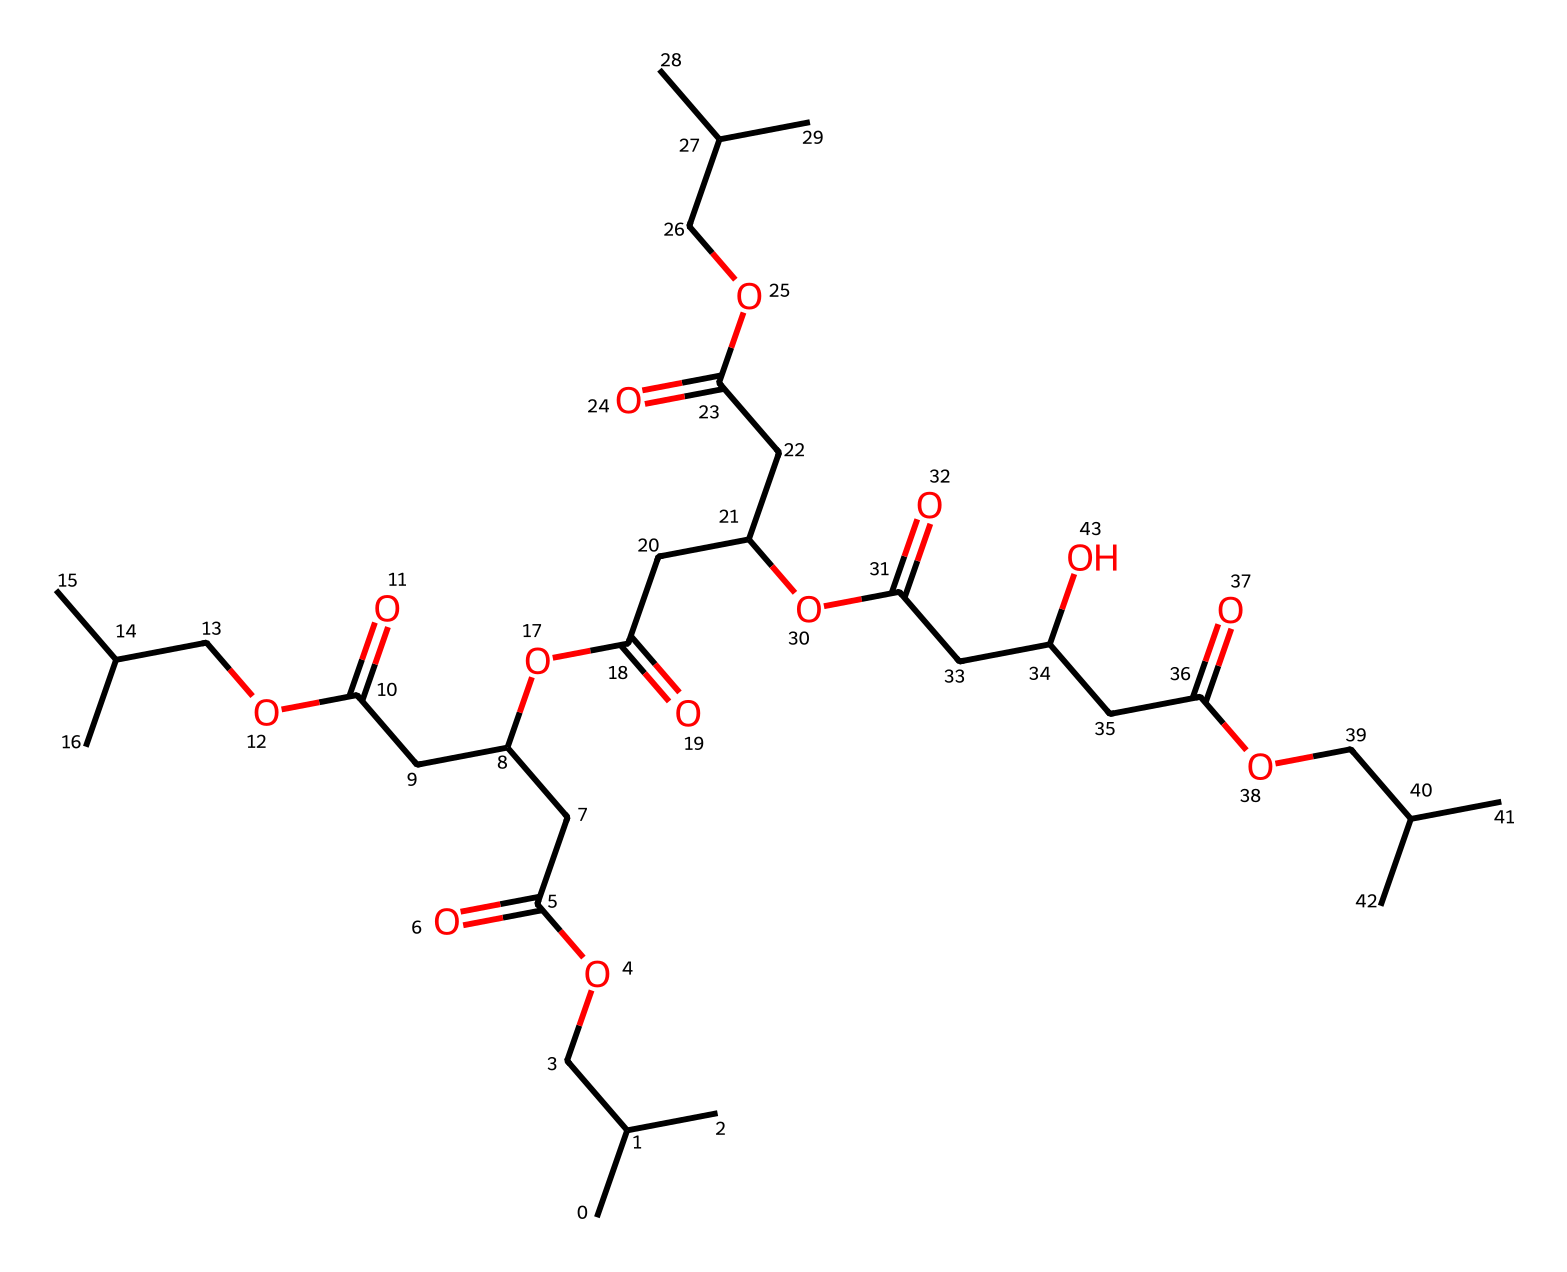What is the primary functional group present in this chemical? The chemical features ester bonds, identifiable from the O=C and O segments within the structure. These are characteristic of esters, derived from carboxylic acids and alcohols.
Answer: ester How many carbon atoms are in this structure? By counting each "C" in the SMILES representation and accounting for the branching, there are 21 carbon atoms in total.
Answer: 21 What type of biomolecule is represented by this chemical? This chemical is a polymer made from biological monomers, typically representing a type of biodegradable plastic used in waste management applications.
Answer: polymer How many ester linkages are present in this molecule? The presence of multiple O=C segments indicates there are three repeating ester linkages, evident in the branched structure of the molecule.
Answer: three Does this chemical exhibit hydrophilic or hydrophobic characteristics? The presence of multiple ester and carboxylic acid groups indicates this molecule is hydrophilic, allowing for interactions with water.
Answer: hydrophilic What role does the carboxylic acid group play in the biodegradability of this polymer? The carboxylic acid group contributes to the chemical's polar characteristics and acts as a point of hydrolysis, which facilitates degradation in the environment.
Answer: hydrolysis 